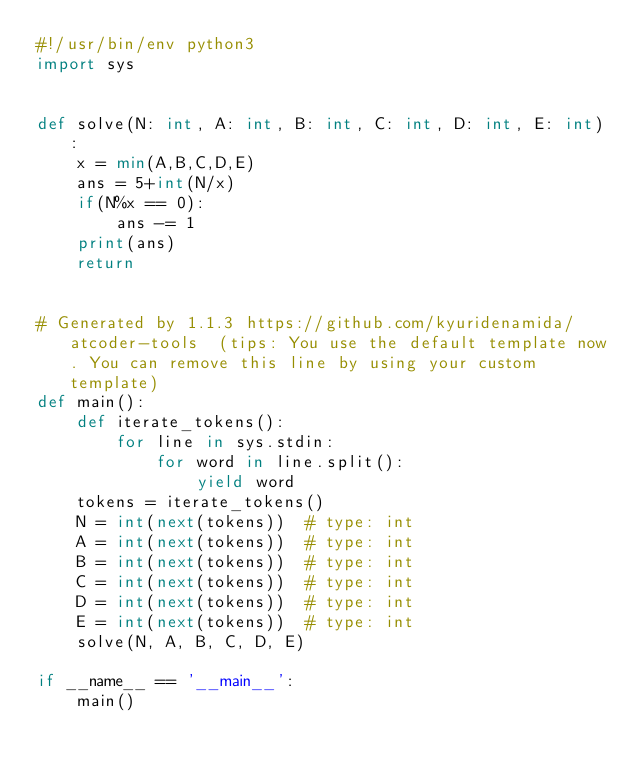<code> <loc_0><loc_0><loc_500><loc_500><_Python_>#!/usr/bin/env python3
import sys


def solve(N: int, A: int, B: int, C: int, D: int, E: int):
    x = min(A,B,C,D,E)
    ans = 5+int(N/x)
    if(N%x == 0):
        ans -= 1
    print(ans)
    return


# Generated by 1.1.3 https://github.com/kyuridenamida/atcoder-tools  (tips: You use the default template now. You can remove this line by using your custom template)
def main():
    def iterate_tokens():
        for line in sys.stdin:
            for word in line.split():
                yield word
    tokens = iterate_tokens()
    N = int(next(tokens))  # type: int
    A = int(next(tokens))  # type: int
    B = int(next(tokens))  # type: int
    C = int(next(tokens))  # type: int
    D = int(next(tokens))  # type: int
    E = int(next(tokens))  # type: int
    solve(N, A, B, C, D, E)

if __name__ == '__main__':
    main()
</code> 